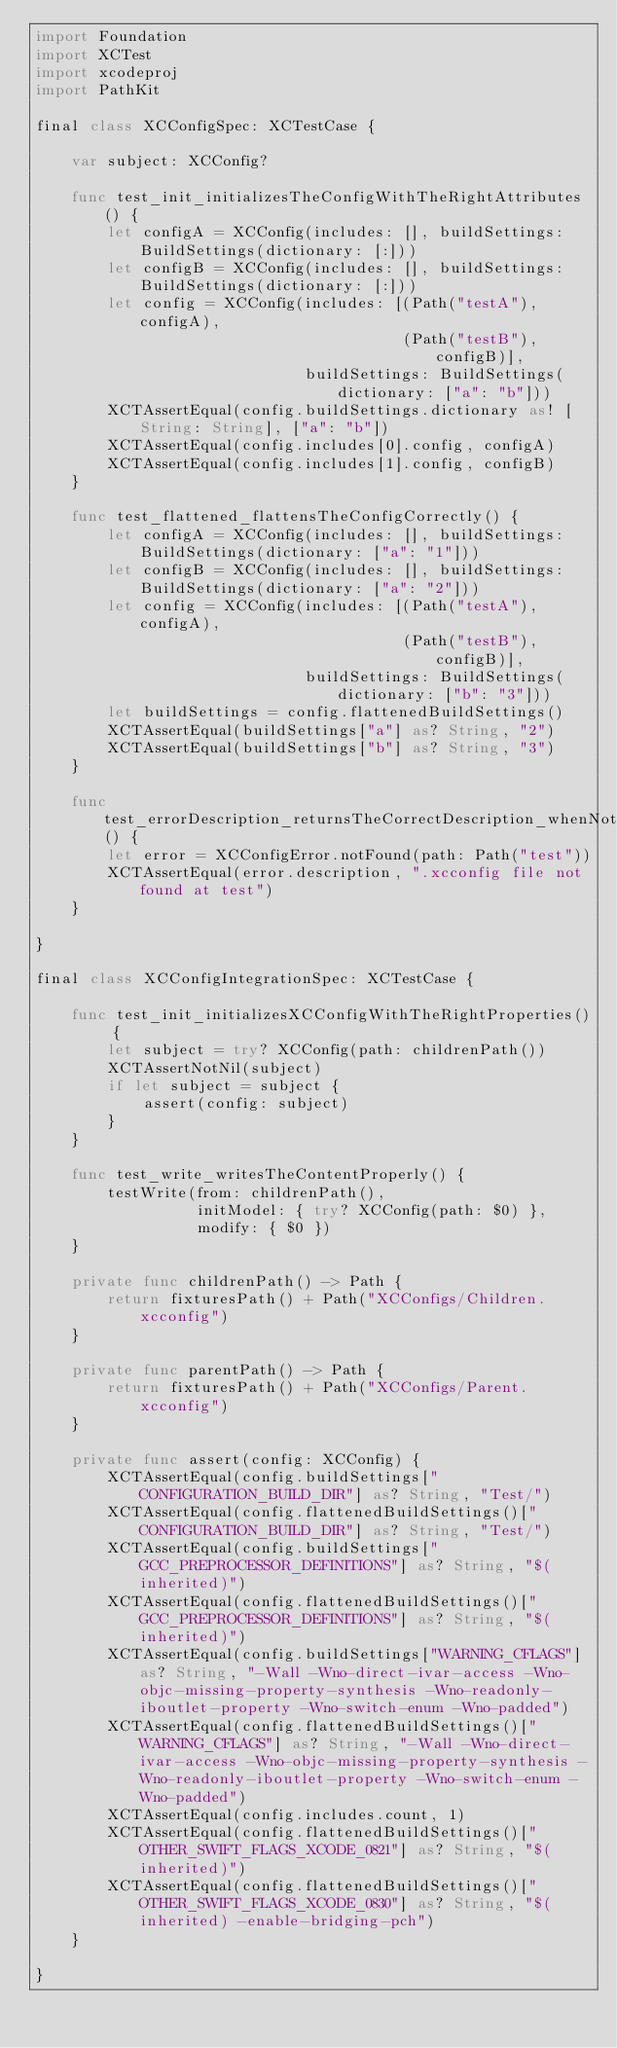Convert code to text. <code><loc_0><loc_0><loc_500><loc_500><_Swift_>import Foundation
import XCTest
import xcodeproj
import PathKit

final class XCConfigSpec: XCTestCase {
    
    var subject: XCConfig?
    
    func test_init_initializesTheConfigWithTheRightAttributes() {
        let configA = XCConfig(includes: [], buildSettings: BuildSettings(dictionary: [:]))
        let configB = XCConfig(includes: [], buildSettings: BuildSettings(dictionary: [:]))
        let config = XCConfig(includes: [(Path("testA"), configA),
                                         (Path("testB"), configB)],
                              buildSettings: BuildSettings(dictionary: ["a": "b"]))
        XCTAssertEqual(config.buildSettings.dictionary as! [String: String], ["a": "b"])
        XCTAssertEqual(config.includes[0].config, configA)
        XCTAssertEqual(config.includes[1].config, configB)
    }
    
    func test_flattened_flattensTheConfigCorrectly() {
        let configA = XCConfig(includes: [], buildSettings: BuildSettings(dictionary: ["a": "1"]))
        let configB = XCConfig(includes: [], buildSettings: BuildSettings(dictionary: ["a": "2"]))
        let config = XCConfig(includes: [(Path("testA"), configA),
                                         (Path("testB"), configB)],
                              buildSettings: BuildSettings(dictionary: ["b": "3"]))
        let buildSettings = config.flattenedBuildSettings()
        XCTAssertEqual(buildSettings["a"] as? String, "2")
        XCTAssertEqual(buildSettings["b"] as? String, "3")
    }
    
    func test_errorDescription_returnsTheCorrectDescription_whenNotFound() {
        let error = XCConfigError.notFound(path: Path("test"))
        XCTAssertEqual(error.description, ".xcconfig file not found at test")
    }
    
}

final class XCConfigIntegrationSpec: XCTestCase {
    
    func test_init_initializesXCConfigWithTheRightProperties() {
        let subject = try? XCConfig(path: childrenPath())
        XCTAssertNotNil(subject)
        if let subject = subject {
            assert(config: subject)
        }
    }
    
    func test_write_writesTheContentProperly() {
        testWrite(from: childrenPath(),
                  initModel: { try? XCConfig(path: $0) },
                  modify: { $0 })
    }
    
    private func childrenPath() -> Path {
        return fixturesPath() + Path("XCConfigs/Children.xcconfig")
    }
    
    private func parentPath() -> Path {
        return fixturesPath() + Path("XCConfigs/Parent.xcconfig")
    }
    
    private func assert(config: XCConfig) {
        XCTAssertEqual(config.buildSettings["CONFIGURATION_BUILD_DIR"] as? String, "Test/")
        XCTAssertEqual(config.flattenedBuildSettings()["CONFIGURATION_BUILD_DIR"] as? String, "Test/")
        XCTAssertEqual(config.buildSettings["GCC_PREPROCESSOR_DEFINITIONS"] as? String, "$(inherited)")
        XCTAssertEqual(config.flattenedBuildSettings()["GCC_PREPROCESSOR_DEFINITIONS"] as? String, "$(inherited)")
        XCTAssertEqual(config.buildSettings["WARNING_CFLAGS"] as? String, "-Wall -Wno-direct-ivar-access -Wno-objc-missing-property-synthesis -Wno-readonly-iboutlet-property -Wno-switch-enum -Wno-padded")
        XCTAssertEqual(config.flattenedBuildSettings()["WARNING_CFLAGS"] as? String, "-Wall -Wno-direct-ivar-access -Wno-objc-missing-property-synthesis -Wno-readonly-iboutlet-property -Wno-switch-enum -Wno-padded")
        XCTAssertEqual(config.includes.count, 1)
        XCTAssertEqual(config.flattenedBuildSettings()["OTHER_SWIFT_FLAGS_XCODE_0821"] as? String, "$(inherited)")
        XCTAssertEqual(config.flattenedBuildSettings()["OTHER_SWIFT_FLAGS_XCODE_0830"] as? String, "$(inherited) -enable-bridging-pch")
    }
    
}

</code> 